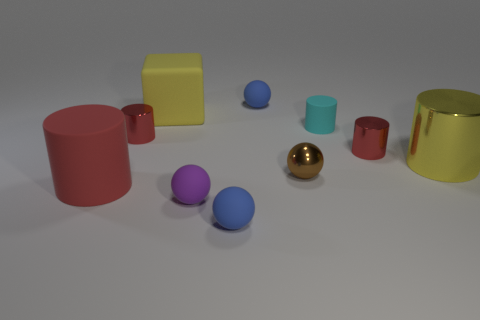How many blue balls must be subtracted to get 1 blue balls? 1 Subtract all matte spheres. How many spheres are left? 1 Subtract all brown balls. How many balls are left? 3 Add 7 big rubber cubes. How many big rubber cubes exist? 8 Subtract 0 red spheres. How many objects are left? 10 Subtract all cubes. How many objects are left? 9 Subtract 2 cylinders. How many cylinders are left? 3 Subtract all green balls. Subtract all yellow blocks. How many balls are left? 4 Subtract all yellow cubes. How many gray cylinders are left? 0 Subtract all tiny gray cubes. Subtract all balls. How many objects are left? 6 